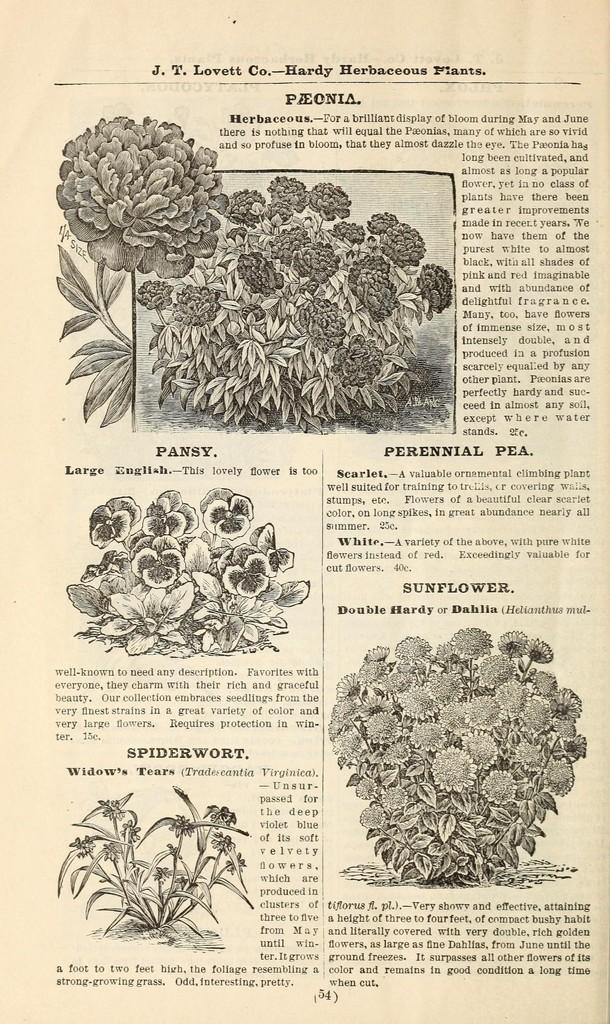What is the main subject of the image? There is a plants poster in the image. Can you describe the poster in more detail? The poster features images or information related to plants. Where is the deer located in the image? There is no deer present in the image; it only features a plants poster. What type of burst can be seen in the image? There is no burst present in the image; it only features a plants poster. 